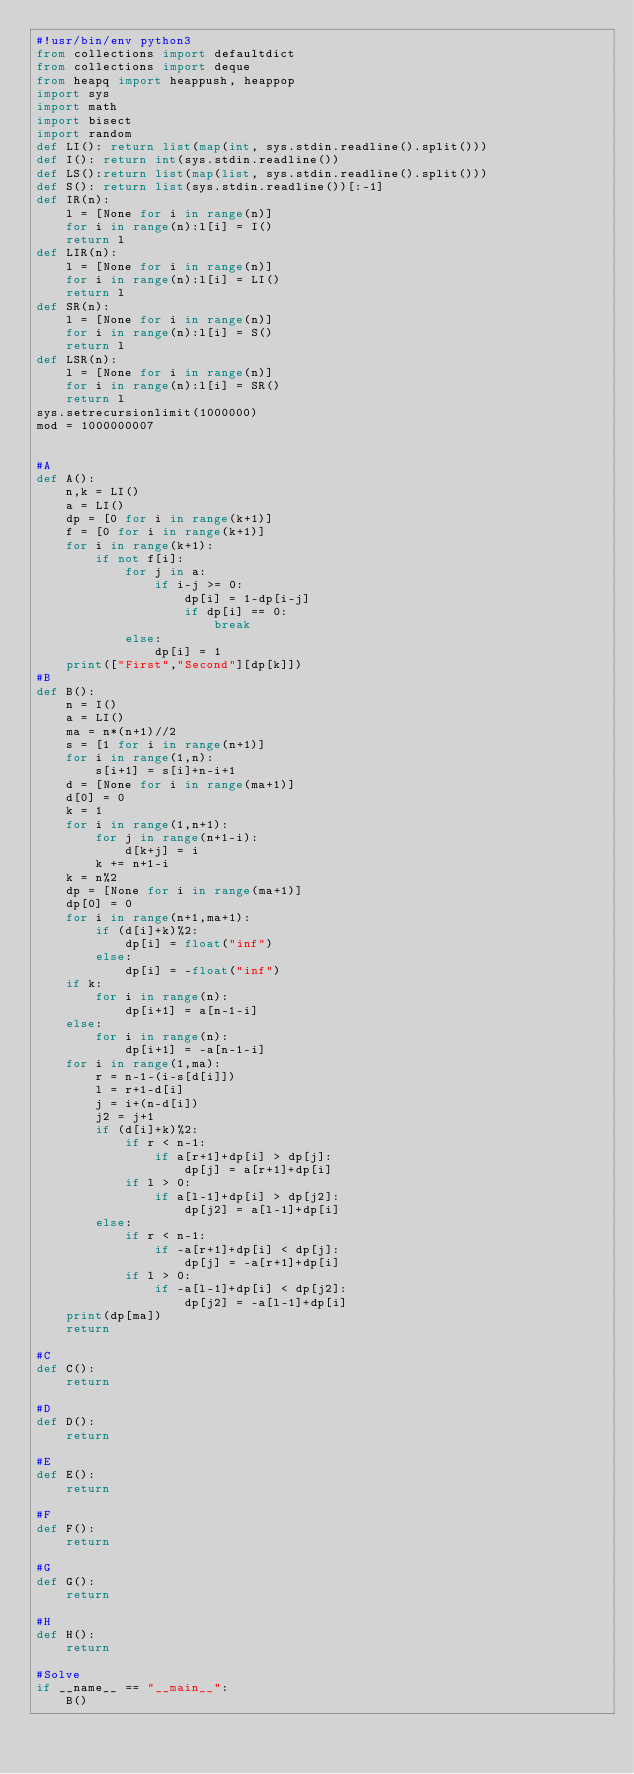<code> <loc_0><loc_0><loc_500><loc_500><_Python_>#!usr/bin/env python3
from collections import defaultdict
from collections import deque
from heapq import heappush, heappop
import sys
import math
import bisect
import random
def LI(): return list(map(int, sys.stdin.readline().split()))
def I(): return int(sys.stdin.readline())
def LS():return list(map(list, sys.stdin.readline().split()))
def S(): return list(sys.stdin.readline())[:-1]
def IR(n):
    l = [None for i in range(n)]
    for i in range(n):l[i] = I()
    return l
def LIR(n):
    l = [None for i in range(n)]
    for i in range(n):l[i] = LI()
    return l
def SR(n):
    l = [None for i in range(n)]
    for i in range(n):l[i] = S()
    return l
def LSR(n):
    l = [None for i in range(n)]
    for i in range(n):l[i] = SR()
    return l
sys.setrecursionlimit(1000000)
mod = 1000000007


#A
def A():
    n,k = LI()
    a = LI()
    dp = [0 for i in range(k+1)]
    f = [0 for i in range(k+1)]
    for i in range(k+1):
        if not f[i]:
            for j in a:
                if i-j >= 0:
                    dp[i] = 1-dp[i-j]
                    if dp[i] == 0:
                        break
            else:
                dp[i] = 1
    print(["First","Second"][dp[k]])
#B
def B():
    n = I()
    a = LI()
    ma = n*(n+1)//2
    s = [1 for i in range(n+1)]
    for i in range(1,n):
        s[i+1] = s[i]+n-i+1
    d = [None for i in range(ma+1)]
    d[0] = 0
    k = 1
    for i in range(1,n+1):
        for j in range(n+1-i):
            d[k+j] = i
        k += n+1-i
    k = n%2
    dp = [None for i in range(ma+1)]
    dp[0] = 0
    for i in range(n+1,ma+1):
        if (d[i]+k)%2:
            dp[i] = float("inf")
        else:
            dp[i] = -float("inf")
    if k:
        for i in range(n):
            dp[i+1] = a[n-1-i]
    else:
        for i in range(n):
            dp[i+1] = -a[n-1-i]
    for i in range(1,ma):
        r = n-1-(i-s[d[i]])
        l = r+1-d[i]
        j = i+(n-d[i])
        j2 = j+1
        if (d[i]+k)%2:
            if r < n-1:
                if a[r+1]+dp[i] > dp[j]:
                    dp[j] = a[r+1]+dp[i]
            if l > 0:
                if a[l-1]+dp[i] > dp[j2]:
                    dp[j2] = a[l-1]+dp[i]
        else:
            if r < n-1:
                if -a[r+1]+dp[i] < dp[j]:
                    dp[j] = -a[r+1]+dp[i]
            if l > 0:
                if -a[l-1]+dp[i] < dp[j2]:
                    dp[j2] = -a[l-1]+dp[i]
    print(dp[ma])
    return

#C
def C():
    return

#D
def D():
    return

#E
def E():
    return

#F
def F():
    return

#G
def G():
    return

#H
def H():
    return

#Solve
if __name__ == "__main__":
    B()
</code> 